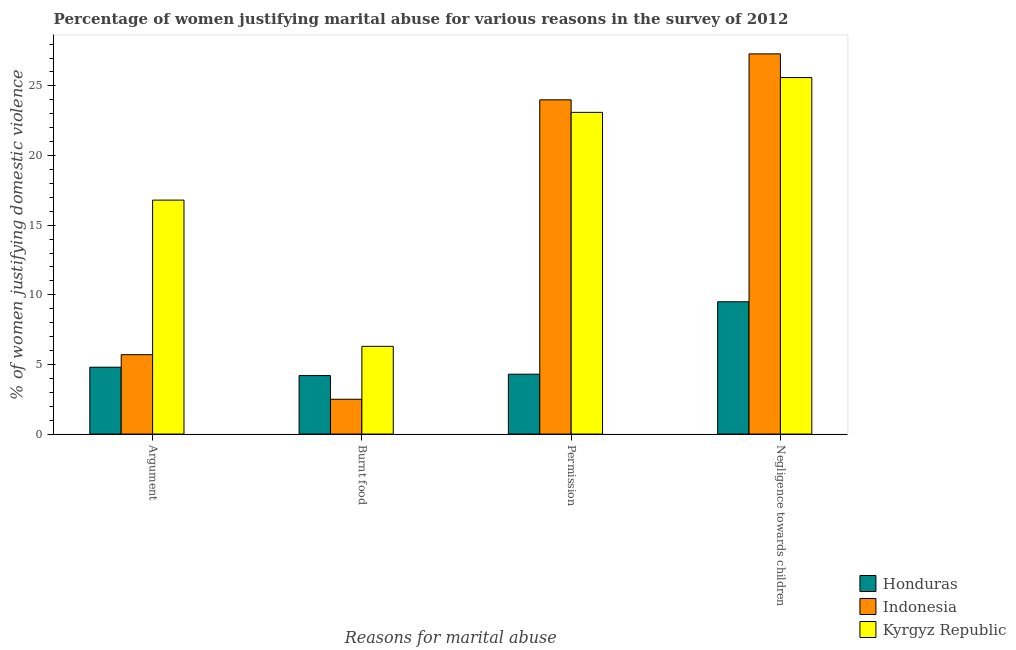How many bars are there on the 3rd tick from the left?
Provide a short and direct response. 3. What is the label of the 3rd group of bars from the left?
Provide a succinct answer. Permission. What is the percentage of women justifying abuse for going without permission in Indonesia?
Offer a terse response. 24. Across all countries, what is the maximum percentage of women justifying abuse for showing negligence towards children?
Your response must be concise. 27.3. Across all countries, what is the minimum percentage of women justifying abuse in the case of an argument?
Keep it short and to the point. 4.8. In which country was the percentage of women justifying abuse for going without permission minimum?
Your response must be concise. Honduras. What is the total percentage of women justifying abuse in the case of an argument in the graph?
Provide a short and direct response. 27.3. What is the difference between the percentage of women justifying abuse for showing negligence towards children in Honduras and that in Indonesia?
Your answer should be compact. -17.8. What is the difference between the percentage of women justifying abuse in the case of an argument in Indonesia and the percentage of women justifying abuse for burning food in Kyrgyz Republic?
Make the answer very short. -0.6. What is the average percentage of women justifying abuse for burning food per country?
Keep it short and to the point. 4.33. What is the ratio of the percentage of women justifying abuse for burning food in Indonesia to that in Honduras?
Your answer should be compact. 0.6. Is the percentage of women justifying abuse for showing negligence towards children in Honduras less than that in Kyrgyz Republic?
Your response must be concise. Yes. Is the difference between the percentage of women justifying abuse in the case of an argument in Kyrgyz Republic and Honduras greater than the difference between the percentage of women justifying abuse for showing negligence towards children in Kyrgyz Republic and Honduras?
Offer a terse response. No. What is the difference between the highest and the second highest percentage of women justifying abuse for burning food?
Give a very brief answer. 2.1. In how many countries, is the percentage of women justifying abuse in the case of an argument greater than the average percentage of women justifying abuse in the case of an argument taken over all countries?
Make the answer very short. 1. Is it the case that in every country, the sum of the percentage of women justifying abuse for going without permission and percentage of women justifying abuse for showing negligence towards children is greater than the sum of percentage of women justifying abuse in the case of an argument and percentage of women justifying abuse for burning food?
Provide a succinct answer. No. What does the 1st bar from the left in Negligence towards children represents?
Provide a succinct answer. Honduras. What does the 3rd bar from the right in Argument represents?
Make the answer very short. Honduras. Is it the case that in every country, the sum of the percentage of women justifying abuse in the case of an argument and percentage of women justifying abuse for burning food is greater than the percentage of women justifying abuse for going without permission?
Offer a very short reply. No. Are all the bars in the graph horizontal?
Ensure brevity in your answer.  No. What is the difference between two consecutive major ticks on the Y-axis?
Give a very brief answer. 5. Are the values on the major ticks of Y-axis written in scientific E-notation?
Ensure brevity in your answer.  No. Does the graph contain any zero values?
Ensure brevity in your answer.  No. Does the graph contain grids?
Your answer should be very brief. No. How are the legend labels stacked?
Keep it short and to the point. Vertical. What is the title of the graph?
Your answer should be very brief. Percentage of women justifying marital abuse for various reasons in the survey of 2012. What is the label or title of the X-axis?
Offer a terse response. Reasons for marital abuse. What is the label or title of the Y-axis?
Your answer should be very brief. % of women justifying domestic violence. What is the % of women justifying domestic violence in Indonesia in Argument?
Your answer should be compact. 5.7. What is the % of women justifying domestic violence in Indonesia in Burnt food?
Ensure brevity in your answer.  2.5. What is the % of women justifying domestic violence in Indonesia in Permission?
Provide a short and direct response. 24. What is the % of women justifying domestic violence in Kyrgyz Republic in Permission?
Make the answer very short. 23.1. What is the % of women justifying domestic violence in Indonesia in Negligence towards children?
Keep it short and to the point. 27.3. What is the % of women justifying domestic violence in Kyrgyz Republic in Negligence towards children?
Provide a short and direct response. 25.6. Across all Reasons for marital abuse, what is the maximum % of women justifying domestic violence of Indonesia?
Your response must be concise. 27.3. Across all Reasons for marital abuse, what is the maximum % of women justifying domestic violence in Kyrgyz Republic?
Your answer should be very brief. 25.6. Across all Reasons for marital abuse, what is the minimum % of women justifying domestic violence of Honduras?
Your response must be concise. 4.2. Across all Reasons for marital abuse, what is the minimum % of women justifying domestic violence in Indonesia?
Your answer should be very brief. 2.5. What is the total % of women justifying domestic violence of Honduras in the graph?
Keep it short and to the point. 22.8. What is the total % of women justifying domestic violence in Indonesia in the graph?
Make the answer very short. 59.5. What is the total % of women justifying domestic violence in Kyrgyz Republic in the graph?
Make the answer very short. 71.8. What is the difference between the % of women justifying domestic violence in Honduras in Argument and that in Burnt food?
Offer a very short reply. 0.6. What is the difference between the % of women justifying domestic violence of Kyrgyz Republic in Argument and that in Burnt food?
Give a very brief answer. 10.5. What is the difference between the % of women justifying domestic violence in Indonesia in Argument and that in Permission?
Ensure brevity in your answer.  -18.3. What is the difference between the % of women justifying domestic violence of Kyrgyz Republic in Argument and that in Permission?
Keep it short and to the point. -6.3. What is the difference between the % of women justifying domestic violence of Indonesia in Argument and that in Negligence towards children?
Offer a very short reply. -21.6. What is the difference between the % of women justifying domestic violence of Kyrgyz Republic in Argument and that in Negligence towards children?
Your answer should be very brief. -8.8. What is the difference between the % of women justifying domestic violence of Indonesia in Burnt food and that in Permission?
Offer a very short reply. -21.5. What is the difference between the % of women justifying domestic violence in Kyrgyz Republic in Burnt food and that in Permission?
Ensure brevity in your answer.  -16.8. What is the difference between the % of women justifying domestic violence of Indonesia in Burnt food and that in Negligence towards children?
Ensure brevity in your answer.  -24.8. What is the difference between the % of women justifying domestic violence in Kyrgyz Republic in Burnt food and that in Negligence towards children?
Offer a terse response. -19.3. What is the difference between the % of women justifying domestic violence in Indonesia in Permission and that in Negligence towards children?
Offer a very short reply. -3.3. What is the difference between the % of women justifying domestic violence of Honduras in Argument and the % of women justifying domestic violence of Indonesia in Burnt food?
Give a very brief answer. 2.3. What is the difference between the % of women justifying domestic violence of Honduras in Argument and the % of women justifying domestic violence of Indonesia in Permission?
Your answer should be compact. -19.2. What is the difference between the % of women justifying domestic violence of Honduras in Argument and the % of women justifying domestic violence of Kyrgyz Republic in Permission?
Your answer should be compact. -18.3. What is the difference between the % of women justifying domestic violence of Indonesia in Argument and the % of women justifying domestic violence of Kyrgyz Republic in Permission?
Your answer should be very brief. -17.4. What is the difference between the % of women justifying domestic violence of Honduras in Argument and the % of women justifying domestic violence of Indonesia in Negligence towards children?
Your response must be concise. -22.5. What is the difference between the % of women justifying domestic violence in Honduras in Argument and the % of women justifying domestic violence in Kyrgyz Republic in Negligence towards children?
Your answer should be very brief. -20.8. What is the difference between the % of women justifying domestic violence of Indonesia in Argument and the % of women justifying domestic violence of Kyrgyz Republic in Negligence towards children?
Provide a succinct answer. -19.9. What is the difference between the % of women justifying domestic violence of Honduras in Burnt food and the % of women justifying domestic violence of Indonesia in Permission?
Your answer should be very brief. -19.8. What is the difference between the % of women justifying domestic violence in Honduras in Burnt food and the % of women justifying domestic violence in Kyrgyz Republic in Permission?
Make the answer very short. -18.9. What is the difference between the % of women justifying domestic violence of Indonesia in Burnt food and the % of women justifying domestic violence of Kyrgyz Republic in Permission?
Keep it short and to the point. -20.6. What is the difference between the % of women justifying domestic violence in Honduras in Burnt food and the % of women justifying domestic violence in Indonesia in Negligence towards children?
Give a very brief answer. -23.1. What is the difference between the % of women justifying domestic violence in Honduras in Burnt food and the % of women justifying domestic violence in Kyrgyz Republic in Negligence towards children?
Offer a very short reply. -21.4. What is the difference between the % of women justifying domestic violence in Indonesia in Burnt food and the % of women justifying domestic violence in Kyrgyz Republic in Negligence towards children?
Ensure brevity in your answer.  -23.1. What is the difference between the % of women justifying domestic violence in Honduras in Permission and the % of women justifying domestic violence in Kyrgyz Republic in Negligence towards children?
Offer a very short reply. -21.3. What is the difference between the % of women justifying domestic violence in Indonesia in Permission and the % of women justifying domestic violence in Kyrgyz Republic in Negligence towards children?
Your answer should be very brief. -1.6. What is the average % of women justifying domestic violence of Indonesia per Reasons for marital abuse?
Provide a short and direct response. 14.88. What is the average % of women justifying domestic violence of Kyrgyz Republic per Reasons for marital abuse?
Your response must be concise. 17.95. What is the difference between the % of women justifying domestic violence of Honduras and % of women justifying domestic violence of Indonesia in Argument?
Your response must be concise. -0.9. What is the difference between the % of women justifying domestic violence in Indonesia and % of women justifying domestic violence in Kyrgyz Republic in Argument?
Ensure brevity in your answer.  -11.1. What is the difference between the % of women justifying domestic violence in Honduras and % of women justifying domestic violence in Indonesia in Permission?
Offer a very short reply. -19.7. What is the difference between the % of women justifying domestic violence of Honduras and % of women justifying domestic violence of Kyrgyz Republic in Permission?
Ensure brevity in your answer.  -18.8. What is the difference between the % of women justifying domestic violence in Honduras and % of women justifying domestic violence in Indonesia in Negligence towards children?
Provide a succinct answer. -17.8. What is the difference between the % of women justifying domestic violence in Honduras and % of women justifying domestic violence in Kyrgyz Republic in Negligence towards children?
Offer a very short reply. -16.1. What is the difference between the % of women justifying domestic violence of Indonesia and % of women justifying domestic violence of Kyrgyz Republic in Negligence towards children?
Offer a terse response. 1.7. What is the ratio of the % of women justifying domestic violence in Honduras in Argument to that in Burnt food?
Provide a short and direct response. 1.14. What is the ratio of the % of women justifying domestic violence in Indonesia in Argument to that in Burnt food?
Keep it short and to the point. 2.28. What is the ratio of the % of women justifying domestic violence of Kyrgyz Republic in Argument to that in Burnt food?
Your answer should be very brief. 2.67. What is the ratio of the % of women justifying domestic violence in Honduras in Argument to that in Permission?
Ensure brevity in your answer.  1.12. What is the ratio of the % of women justifying domestic violence in Indonesia in Argument to that in Permission?
Offer a very short reply. 0.24. What is the ratio of the % of women justifying domestic violence of Kyrgyz Republic in Argument to that in Permission?
Give a very brief answer. 0.73. What is the ratio of the % of women justifying domestic violence in Honduras in Argument to that in Negligence towards children?
Your response must be concise. 0.51. What is the ratio of the % of women justifying domestic violence in Indonesia in Argument to that in Negligence towards children?
Your response must be concise. 0.21. What is the ratio of the % of women justifying domestic violence of Kyrgyz Republic in Argument to that in Negligence towards children?
Your answer should be very brief. 0.66. What is the ratio of the % of women justifying domestic violence in Honduras in Burnt food to that in Permission?
Your answer should be very brief. 0.98. What is the ratio of the % of women justifying domestic violence of Indonesia in Burnt food to that in Permission?
Your answer should be compact. 0.1. What is the ratio of the % of women justifying domestic violence in Kyrgyz Republic in Burnt food to that in Permission?
Offer a terse response. 0.27. What is the ratio of the % of women justifying domestic violence of Honduras in Burnt food to that in Negligence towards children?
Ensure brevity in your answer.  0.44. What is the ratio of the % of women justifying domestic violence in Indonesia in Burnt food to that in Negligence towards children?
Give a very brief answer. 0.09. What is the ratio of the % of women justifying domestic violence in Kyrgyz Republic in Burnt food to that in Negligence towards children?
Provide a succinct answer. 0.25. What is the ratio of the % of women justifying domestic violence in Honduras in Permission to that in Negligence towards children?
Your answer should be very brief. 0.45. What is the ratio of the % of women justifying domestic violence in Indonesia in Permission to that in Negligence towards children?
Offer a terse response. 0.88. What is the ratio of the % of women justifying domestic violence of Kyrgyz Republic in Permission to that in Negligence towards children?
Keep it short and to the point. 0.9. What is the difference between the highest and the second highest % of women justifying domestic violence in Honduras?
Provide a succinct answer. 4.7. What is the difference between the highest and the second highest % of women justifying domestic violence in Indonesia?
Your response must be concise. 3.3. What is the difference between the highest and the second highest % of women justifying domestic violence in Kyrgyz Republic?
Offer a terse response. 2.5. What is the difference between the highest and the lowest % of women justifying domestic violence of Honduras?
Your response must be concise. 5.3. What is the difference between the highest and the lowest % of women justifying domestic violence in Indonesia?
Your response must be concise. 24.8. What is the difference between the highest and the lowest % of women justifying domestic violence in Kyrgyz Republic?
Offer a terse response. 19.3. 